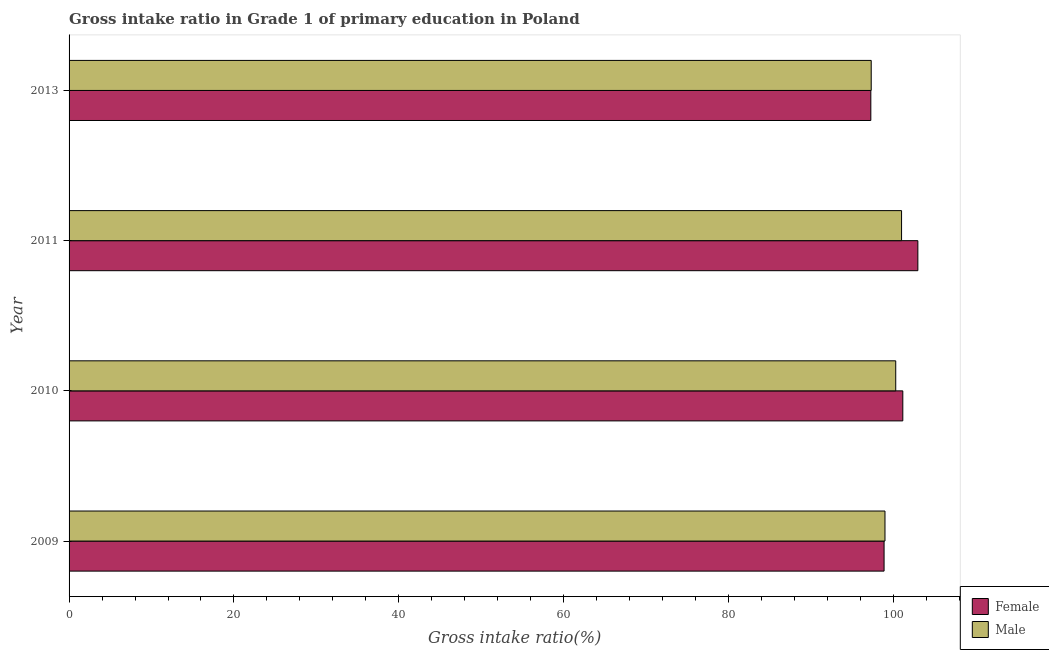How many different coloured bars are there?
Your response must be concise. 2. How many groups of bars are there?
Your response must be concise. 4. What is the label of the 1st group of bars from the top?
Ensure brevity in your answer.  2013. What is the gross intake ratio(male) in 2010?
Keep it short and to the point. 100.27. Across all years, what is the maximum gross intake ratio(female)?
Give a very brief answer. 102.95. Across all years, what is the minimum gross intake ratio(male)?
Give a very brief answer. 97.3. In which year was the gross intake ratio(male) maximum?
Make the answer very short. 2011. What is the total gross intake ratio(female) in the graph?
Your response must be concise. 400.18. What is the difference between the gross intake ratio(male) in 2010 and that in 2013?
Ensure brevity in your answer.  2.97. What is the difference between the gross intake ratio(male) in 2010 and the gross intake ratio(female) in 2009?
Make the answer very short. 1.41. What is the average gross intake ratio(female) per year?
Keep it short and to the point. 100.05. In the year 2009, what is the difference between the gross intake ratio(male) and gross intake ratio(female)?
Make the answer very short. 0.11. In how many years, is the gross intake ratio(female) greater than 100 %?
Your answer should be very brief. 2. What is the ratio of the gross intake ratio(male) in 2011 to that in 2013?
Offer a terse response. 1.04. Is the difference between the gross intake ratio(male) in 2010 and 2011 greater than the difference between the gross intake ratio(female) in 2010 and 2011?
Give a very brief answer. Yes. What is the difference between the highest and the second highest gross intake ratio(male)?
Ensure brevity in your answer.  0.71. In how many years, is the gross intake ratio(female) greater than the average gross intake ratio(female) taken over all years?
Offer a very short reply. 2. Is the sum of the gross intake ratio(female) in 2009 and 2013 greater than the maximum gross intake ratio(male) across all years?
Keep it short and to the point. Yes. What does the 1st bar from the top in 2010 represents?
Give a very brief answer. Male. What does the 2nd bar from the bottom in 2013 represents?
Your response must be concise. Male. How many bars are there?
Provide a short and direct response. 8. Are all the bars in the graph horizontal?
Provide a short and direct response. Yes. How many years are there in the graph?
Provide a short and direct response. 4. What is the difference between two consecutive major ticks on the X-axis?
Provide a short and direct response. 20. Are the values on the major ticks of X-axis written in scientific E-notation?
Make the answer very short. No. Does the graph contain grids?
Your answer should be very brief. No. How many legend labels are there?
Provide a succinct answer. 2. What is the title of the graph?
Keep it short and to the point. Gross intake ratio in Grade 1 of primary education in Poland. Does "Mobile cellular" appear as one of the legend labels in the graph?
Ensure brevity in your answer.  No. What is the label or title of the X-axis?
Offer a very short reply. Gross intake ratio(%). What is the Gross intake ratio(%) of Female in 2009?
Provide a succinct answer. 98.85. What is the Gross intake ratio(%) in Male in 2009?
Provide a succinct answer. 98.96. What is the Gross intake ratio(%) of Female in 2010?
Offer a very short reply. 101.13. What is the Gross intake ratio(%) of Male in 2010?
Ensure brevity in your answer.  100.27. What is the Gross intake ratio(%) of Female in 2011?
Offer a very short reply. 102.95. What is the Gross intake ratio(%) of Male in 2011?
Provide a short and direct response. 100.98. What is the Gross intake ratio(%) of Female in 2013?
Your answer should be very brief. 97.25. What is the Gross intake ratio(%) of Male in 2013?
Your answer should be very brief. 97.3. Across all years, what is the maximum Gross intake ratio(%) in Female?
Your answer should be very brief. 102.95. Across all years, what is the maximum Gross intake ratio(%) of Male?
Ensure brevity in your answer.  100.98. Across all years, what is the minimum Gross intake ratio(%) of Female?
Offer a very short reply. 97.25. Across all years, what is the minimum Gross intake ratio(%) in Male?
Offer a very short reply. 97.3. What is the total Gross intake ratio(%) in Female in the graph?
Your response must be concise. 400.18. What is the total Gross intake ratio(%) in Male in the graph?
Offer a terse response. 397.51. What is the difference between the Gross intake ratio(%) of Female in 2009 and that in 2010?
Provide a succinct answer. -2.27. What is the difference between the Gross intake ratio(%) in Male in 2009 and that in 2010?
Provide a short and direct response. -1.3. What is the difference between the Gross intake ratio(%) of Female in 2009 and that in 2011?
Ensure brevity in your answer.  -4.1. What is the difference between the Gross intake ratio(%) in Male in 2009 and that in 2011?
Provide a short and direct response. -2.01. What is the difference between the Gross intake ratio(%) of Female in 2009 and that in 2013?
Provide a succinct answer. 1.61. What is the difference between the Gross intake ratio(%) in Male in 2009 and that in 2013?
Offer a very short reply. 1.67. What is the difference between the Gross intake ratio(%) in Female in 2010 and that in 2011?
Provide a short and direct response. -1.83. What is the difference between the Gross intake ratio(%) of Male in 2010 and that in 2011?
Make the answer very short. -0.71. What is the difference between the Gross intake ratio(%) in Female in 2010 and that in 2013?
Provide a succinct answer. 3.88. What is the difference between the Gross intake ratio(%) in Male in 2010 and that in 2013?
Give a very brief answer. 2.97. What is the difference between the Gross intake ratio(%) of Female in 2011 and that in 2013?
Ensure brevity in your answer.  5.7. What is the difference between the Gross intake ratio(%) of Male in 2011 and that in 2013?
Your answer should be compact. 3.68. What is the difference between the Gross intake ratio(%) of Female in 2009 and the Gross intake ratio(%) of Male in 2010?
Your answer should be very brief. -1.41. What is the difference between the Gross intake ratio(%) of Female in 2009 and the Gross intake ratio(%) of Male in 2011?
Ensure brevity in your answer.  -2.12. What is the difference between the Gross intake ratio(%) of Female in 2009 and the Gross intake ratio(%) of Male in 2013?
Offer a terse response. 1.56. What is the difference between the Gross intake ratio(%) in Female in 2010 and the Gross intake ratio(%) in Male in 2011?
Ensure brevity in your answer.  0.15. What is the difference between the Gross intake ratio(%) in Female in 2010 and the Gross intake ratio(%) in Male in 2013?
Provide a short and direct response. 3.83. What is the difference between the Gross intake ratio(%) in Female in 2011 and the Gross intake ratio(%) in Male in 2013?
Make the answer very short. 5.66. What is the average Gross intake ratio(%) of Female per year?
Keep it short and to the point. 100.05. What is the average Gross intake ratio(%) in Male per year?
Provide a succinct answer. 99.38. In the year 2009, what is the difference between the Gross intake ratio(%) in Female and Gross intake ratio(%) in Male?
Your response must be concise. -0.11. In the year 2010, what is the difference between the Gross intake ratio(%) in Female and Gross intake ratio(%) in Male?
Provide a succinct answer. 0.86. In the year 2011, what is the difference between the Gross intake ratio(%) in Female and Gross intake ratio(%) in Male?
Give a very brief answer. 1.98. In the year 2013, what is the difference between the Gross intake ratio(%) in Female and Gross intake ratio(%) in Male?
Your response must be concise. -0.05. What is the ratio of the Gross intake ratio(%) in Female in 2009 to that in 2010?
Offer a terse response. 0.98. What is the ratio of the Gross intake ratio(%) in Male in 2009 to that in 2010?
Give a very brief answer. 0.99. What is the ratio of the Gross intake ratio(%) of Female in 2009 to that in 2011?
Keep it short and to the point. 0.96. What is the ratio of the Gross intake ratio(%) of Male in 2009 to that in 2011?
Offer a very short reply. 0.98. What is the ratio of the Gross intake ratio(%) in Female in 2009 to that in 2013?
Ensure brevity in your answer.  1.02. What is the ratio of the Gross intake ratio(%) of Male in 2009 to that in 2013?
Your response must be concise. 1.02. What is the ratio of the Gross intake ratio(%) of Female in 2010 to that in 2011?
Offer a terse response. 0.98. What is the ratio of the Gross intake ratio(%) in Male in 2010 to that in 2011?
Keep it short and to the point. 0.99. What is the ratio of the Gross intake ratio(%) of Female in 2010 to that in 2013?
Keep it short and to the point. 1.04. What is the ratio of the Gross intake ratio(%) of Male in 2010 to that in 2013?
Ensure brevity in your answer.  1.03. What is the ratio of the Gross intake ratio(%) of Female in 2011 to that in 2013?
Give a very brief answer. 1.06. What is the ratio of the Gross intake ratio(%) in Male in 2011 to that in 2013?
Your response must be concise. 1.04. What is the difference between the highest and the second highest Gross intake ratio(%) of Female?
Make the answer very short. 1.83. What is the difference between the highest and the second highest Gross intake ratio(%) of Male?
Your answer should be compact. 0.71. What is the difference between the highest and the lowest Gross intake ratio(%) of Female?
Offer a very short reply. 5.7. What is the difference between the highest and the lowest Gross intake ratio(%) in Male?
Your answer should be very brief. 3.68. 